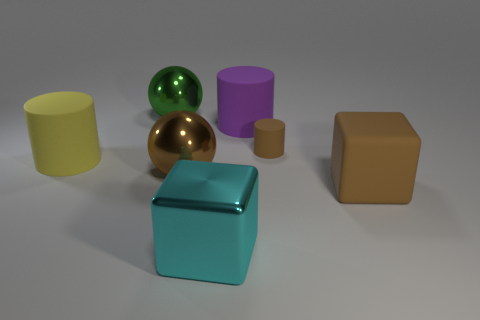Are there any other things that are the same size as the brown rubber cylinder?
Your answer should be very brief. No. What is the shape of the tiny brown object that is the same material as the big purple thing?
Offer a terse response. Cylinder. What number of big cyan shiny objects are the same shape as the large brown rubber thing?
Offer a very short reply. 1. The big rubber object in front of the matte cylinder to the left of the green shiny sphere is what shape?
Provide a succinct answer. Cube. There is a green metal ball that is behind the yellow thing; is its size the same as the tiny cylinder?
Ensure brevity in your answer.  No. What size is the rubber cylinder that is both in front of the big purple cylinder and to the right of the green metal thing?
Give a very brief answer. Small. How many yellow metallic things are the same size as the brown metal sphere?
Offer a terse response. 0. What number of large yellow matte cylinders are in front of the rubber cylinder that is to the left of the cyan block?
Offer a very short reply. 0. Is the color of the big cube that is right of the cyan shiny object the same as the small thing?
Your answer should be compact. Yes. There is a rubber object that is to the left of the cyan metallic block on the left side of the large purple cylinder; is there a cyan shiny object behind it?
Provide a short and direct response. No. 